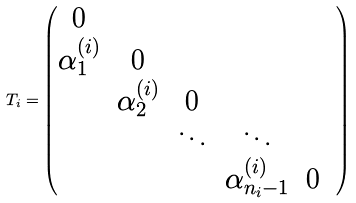<formula> <loc_0><loc_0><loc_500><loc_500>T _ { i } = \begin{pmatrix} 0 & & & & & \\ \alpha _ { 1 } ^ { ( i ) } & 0 & & & & \\ & \alpha _ { 2 } ^ { ( i ) } & 0 & & \\ & & \ddots & \ddots & & \\ & & & \alpha _ { n _ { i } - 1 } ^ { ( i ) } & 0 & \end{pmatrix}</formula> 